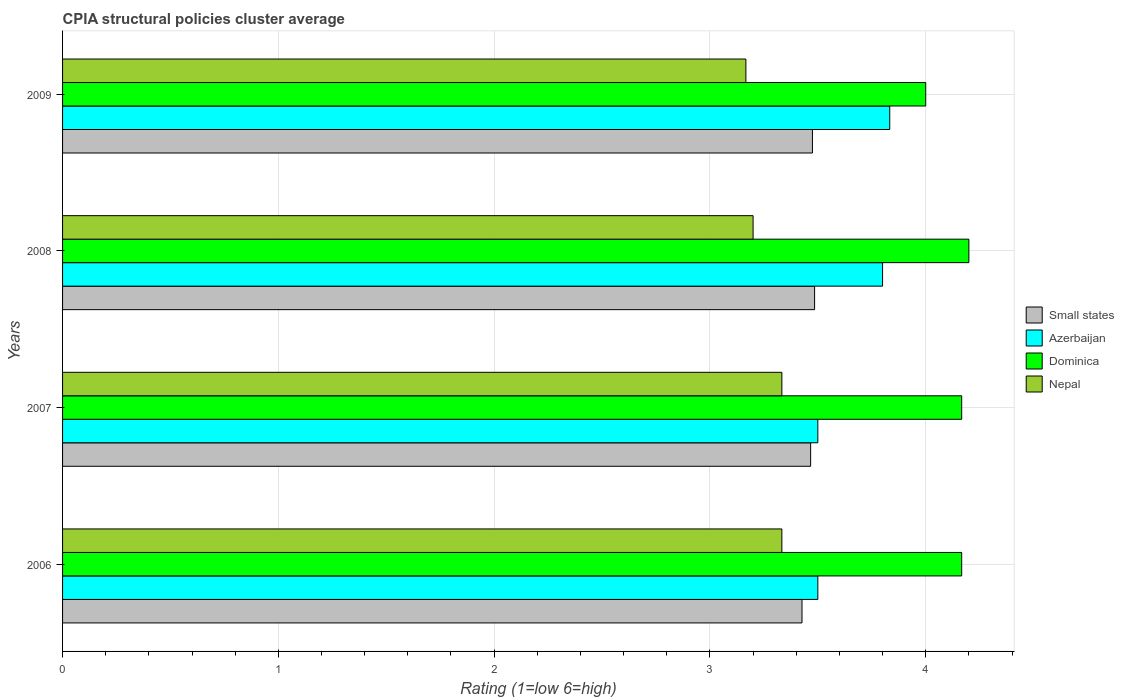Are the number of bars per tick equal to the number of legend labels?
Your response must be concise. Yes. How many bars are there on the 1st tick from the top?
Your answer should be very brief. 4. What is the label of the 2nd group of bars from the top?
Provide a succinct answer. 2008. What is the CPIA rating in Dominica in 2008?
Provide a succinct answer. 4.2. Across all years, what is the maximum CPIA rating in Dominica?
Provide a succinct answer. 4.2. Across all years, what is the minimum CPIA rating in Nepal?
Your answer should be very brief. 3.17. In which year was the CPIA rating in Nepal maximum?
Ensure brevity in your answer.  2006. In which year was the CPIA rating in Small states minimum?
Offer a very short reply. 2006. What is the total CPIA rating in Nepal in the graph?
Make the answer very short. 13.03. What is the difference between the CPIA rating in Nepal in 2006 and that in 2008?
Offer a very short reply. 0.13. What is the difference between the CPIA rating in Small states in 2006 and the CPIA rating in Azerbaijan in 2009?
Ensure brevity in your answer.  -0.41. What is the average CPIA rating in Small states per year?
Give a very brief answer. 3.46. In the year 2006, what is the difference between the CPIA rating in Dominica and CPIA rating in Small states?
Keep it short and to the point. 0.74. What is the ratio of the CPIA rating in Dominica in 2006 to that in 2008?
Offer a very short reply. 0.99. Is the difference between the CPIA rating in Dominica in 2008 and 2009 greater than the difference between the CPIA rating in Small states in 2008 and 2009?
Offer a very short reply. Yes. What is the difference between the highest and the second highest CPIA rating in Dominica?
Your answer should be very brief. 0.03. What is the difference between the highest and the lowest CPIA rating in Nepal?
Ensure brevity in your answer.  0.17. In how many years, is the CPIA rating in Small states greater than the average CPIA rating in Small states taken over all years?
Provide a short and direct response. 3. Is the sum of the CPIA rating in Azerbaijan in 2006 and 2009 greater than the maximum CPIA rating in Nepal across all years?
Ensure brevity in your answer.  Yes. Is it the case that in every year, the sum of the CPIA rating in Dominica and CPIA rating in Small states is greater than the sum of CPIA rating in Azerbaijan and CPIA rating in Nepal?
Make the answer very short. Yes. What does the 2nd bar from the top in 2007 represents?
Keep it short and to the point. Dominica. What does the 2nd bar from the bottom in 2007 represents?
Make the answer very short. Azerbaijan. How many bars are there?
Your response must be concise. 16. How many years are there in the graph?
Offer a very short reply. 4. What is the difference between two consecutive major ticks on the X-axis?
Offer a terse response. 1. Does the graph contain any zero values?
Offer a terse response. No. Does the graph contain grids?
Make the answer very short. Yes. What is the title of the graph?
Your response must be concise. CPIA structural policies cluster average. What is the label or title of the X-axis?
Your answer should be compact. Rating (1=low 6=high). What is the Rating (1=low 6=high) of Small states in 2006?
Offer a terse response. 3.43. What is the Rating (1=low 6=high) of Dominica in 2006?
Give a very brief answer. 4.17. What is the Rating (1=low 6=high) in Nepal in 2006?
Offer a very short reply. 3.33. What is the Rating (1=low 6=high) in Small states in 2007?
Ensure brevity in your answer.  3.47. What is the Rating (1=low 6=high) in Dominica in 2007?
Keep it short and to the point. 4.17. What is the Rating (1=low 6=high) of Nepal in 2007?
Give a very brief answer. 3.33. What is the Rating (1=low 6=high) in Small states in 2008?
Your answer should be compact. 3.48. What is the Rating (1=low 6=high) of Azerbaijan in 2008?
Offer a terse response. 3.8. What is the Rating (1=low 6=high) of Nepal in 2008?
Your answer should be very brief. 3.2. What is the Rating (1=low 6=high) in Small states in 2009?
Offer a very short reply. 3.48. What is the Rating (1=low 6=high) in Azerbaijan in 2009?
Ensure brevity in your answer.  3.83. What is the Rating (1=low 6=high) of Nepal in 2009?
Keep it short and to the point. 3.17. Across all years, what is the maximum Rating (1=low 6=high) of Small states?
Give a very brief answer. 3.48. Across all years, what is the maximum Rating (1=low 6=high) of Azerbaijan?
Provide a short and direct response. 3.83. Across all years, what is the maximum Rating (1=low 6=high) of Dominica?
Give a very brief answer. 4.2. Across all years, what is the maximum Rating (1=low 6=high) of Nepal?
Give a very brief answer. 3.33. Across all years, what is the minimum Rating (1=low 6=high) in Small states?
Provide a short and direct response. 3.43. Across all years, what is the minimum Rating (1=low 6=high) of Azerbaijan?
Your answer should be compact. 3.5. Across all years, what is the minimum Rating (1=low 6=high) in Dominica?
Offer a terse response. 4. Across all years, what is the minimum Rating (1=low 6=high) of Nepal?
Make the answer very short. 3.17. What is the total Rating (1=low 6=high) in Small states in the graph?
Your answer should be very brief. 13.85. What is the total Rating (1=low 6=high) of Azerbaijan in the graph?
Make the answer very short. 14.63. What is the total Rating (1=low 6=high) of Dominica in the graph?
Keep it short and to the point. 16.53. What is the total Rating (1=low 6=high) of Nepal in the graph?
Your response must be concise. 13.03. What is the difference between the Rating (1=low 6=high) in Small states in 2006 and that in 2007?
Your answer should be compact. -0.04. What is the difference between the Rating (1=low 6=high) of Small states in 2006 and that in 2008?
Ensure brevity in your answer.  -0.06. What is the difference between the Rating (1=low 6=high) of Dominica in 2006 and that in 2008?
Keep it short and to the point. -0.03. What is the difference between the Rating (1=low 6=high) in Nepal in 2006 and that in 2008?
Provide a succinct answer. 0.13. What is the difference between the Rating (1=low 6=high) of Small states in 2006 and that in 2009?
Offer a very short reply. -0.05. What is the difference between the Rating (1=low 6=high) in Nepal in 2006 and that in 2009?
Keep it short and to the point. 0.17. What is the difference between the Rating (1=low 6=high) of Small states in 2007 and that in 2008?
Offer a very short reply. -0.02. What is the difference between the Rating (1=low 6=high) in Azerbaijan in 2007 and that in 2008?
Provide a short and direct response. -0.3. What is the difference between the Rating (1=low 6=high) of Dominica in 2007 and that in 2008?
Your response must be concise. -0.03. What is the difference between the Rating (1=low 6=high) of Nepal in 2007 and that in 2008?
Provide a succinct answer. 0.13. What is the difference between the Rating (1=low 6=high) of Small states in 2007 and that in 2009?
Ensure brevity in your answer.  -0.01. What is the difference between the Rating (1=low 6=high) of Small states in 2008 and that in 2009?
Provide a short and direct response. 0.01. What is the difference between the Rating (1=low 6=high) in Azerbaijan in 2008 and that in 2009?
Your answer should be very brief. -0.03. What is the difference between the Rating (1=low 6=high) in Small states in 2006 and the Rating (1=low 6=high) in Azerbaijan in 2007?
Ensure brevity in your answer.  -0.07. What is the difference between the Rating (1=low 6=high) of Small states in 2006 and the Rating (1=low 6=high) of Dominica in 2007?
Offer a very short reply. -0.74. What is the difference between the Rating (1=low 6=high) in Small states in 2006 and the Rating (1=low 6=high) in Nepal in 2007?
Offer a very short reply. 0.09. What is the difference between the Rating (1=low 6=high) in Azerbaijan in 2006 and the Rating (1=low 6=high) in Nepal in 2007?
Your answer should be compact. 0.17. What is the difference between the Rating (1=low 6=high) of Small states in 2006 and the Rating (1=low 6=high) of Azerbaijan in 2008?
Provide a short and direct response. -0.37. What is the difference between the Rating (1=low 6=high) of Small states in 2006 and the Rating (1=low 6=high) of Dominica in 2008?
Ensure brevity in your answer.  -0.77. What is the difference between the Rating (1=low 6=high) in Small states in 2006 and the Rating (1=low 6=high) in Nepal in 2008?
Your answer should be compact. 0.23. What is the difference between the Rating (1=low 6=high) in Dominica in 2006 and the Rating (1=low 6=high) in Nepal in 2008?
Offer a very short reply. 0.97. What is the difference between the Rating (1=low 6=high) in Small states in 2006 and the Rating (1=low 6=high) in Azerbaijan in 2009?
Offer a very short reply. -0.41. What is the difference between the Rating (1=low 6=high) of Small states in 2006 and the Rating (1=low 6=high) of Dominica in 2009?
Provide a succinct answer. -0.57. What is the difference between the Rating (1=low 6=high) in Small states in 2006 and the Rating (1=low 6=high) in Nepal in 2009?
Your answer should be compact. 0.26. What is the difference between the Rating (1=low 6=high) in Small states in 2007 and the Rating (1=low 6=high) in Azerbaijan in 2008?
Your response must be concise. -0.33. What is the difference between the Rating (1=low 6=high) in Small states in 2007 and the Rating (1=low 6=high) in Dominica in 2008?
Provide a short and direct response. -0.73. What is the difference between the Rating (1=low 6=high) of Small states in 2007 and the Rating (1=low 6=high) of Nepal in 2008?
Give a very brief answer. 0.27. What is the difference between the Rating (1=low 6=high) of Dominica in 2007 and the Rating (1=low 6=high) of Nepal in 2008?
Your answer should be compact. 0.97. What is the difference between the Rating (1=low 6=high) in Small states in 2007 and the Rating (1=low 6=high) in Azerbaijan in 2009?
Your response must be concise. -0.37. What is the difference between the Rating (1=low 6=high) of Small states in 2007 and the Rating (1=low 6=high) of Dominica in 2009?
Your answer should be compact. -0.53. What is the difference between the Rating (1=low 6=high) in Small states in 2007 and the Rating (1=low 6=high) in Nepal in 2009?
Your answer should be compact. 0.3. What is the difference between the Rating (1=low 6=high) of Azerbaijan in 2007 and the Rating (1=low 6=high) of Nepal in 2009?
Your response must be concise. 0.33. What is the difference between the Rating (1=low 6=high) of Small states in 2008 and the Rating (1=low 6=high) of Azerbaijan in 2009?
Provide a short and direct response. -0.35. What is the difference between the Rating (1=low 6=high) of Small states in 2008 and the Rating (1=low 6=high) of Dominica in 2009?
Your response must be concise. -0.52. What is the difference between the Rating (1=low 6=high) of Small states in 2008 and the Rating (1=low 6=high) of Nepal in 2009?
Offer a very short reply. 0.32. What is the difference between the Rating (1=low 6=high) in Azerbaijan in 2008 and the Rating (1=low 6=high) in Dominica in 2009?
Ensure brevity in your answer.  -0.2. What is the difference between the Rating (1=low 6=high) of Azerbaijan in 2008 and the Rating (1=low 6=high) of Nepal in 2009?
Make the answer very short. 0.63. What is the difference between the Rating (1=low 6=high) in Dominica in 2008 and the Rating (1=low 6=high) in Nepal in 2009?
Provide a short and direct response. 1.03. What is the average Rating (1=low 6=high) in Small states per year?
Offer a terse response. 3.46. What is the average Rating (1=low 6=high) of Azerbaijan per year?
Give a very brief answer. 3.66. What is the average Rating (1=low 6=high) in Dominica per year?
Provide a short and direct response. 4.13. What is the average Rating (1=low 6=high) of Nepal per year?
Your answer should be compact. 3.26. In the year 2006, what is the difference between the Rating (1=low 6=high) in Small states and Rating (1=low 6=high) in Azerbaijan?
Ensure brevity in your answer.  -0.07. In the year 2006, what is the difference between the Rating (1=low 6=high) in Small states and Rating (1=low 6=high) in Dominica?
Ensure brevity in your answer.  -0.74. In the year 2006, what is the difference between the Rating (1=low 6=high) in Small states and Rating (1=low 6=high) in Nepal?
Provide a succinct answer. 0.09. In the year 2006, what is the difference between the Rating (1=low 6=high) of Azerbaijan and Rating (1=low 6=high) of Dominica?
Offer a terse response. -0.67. In the year 2006, what is the difference between the Rating (1=low 6=high) in Azerbaijan and Rating (1=low 6=high) in Nepal?
Offer a very short reply. 0.17. In the year 2006, what is the difference between the Rating (1=low 6=high) of Dominica and Rating (1=low 6=high) of Nepal?
Provide a succinct answer. 0.83. In the year 2007, what is the difference between the Rating (1=low 6=high) of Small states and Rating (1=low 6=high) of Azerbaijan?
Provide a short and direct response. -0.03. In the year 2007, what is the difference between the Rating (1=low 6=high) of Small states and Rating (1=low 6=high) of Nepal?
Ensure brevity in your answer.  0.13. In the year 2007, what is the difference between the Rating (1=low 6=high) in Azerbaijan and Rating (1=low 6=high) in Nepal?
Your answer should be very brief. 0.17. In the year 2008, what is the difference between the Rating (1=low 6=high) in Small states and Rating (1=low 6=high) in Azerbaijan?
Make the answer very short. -0.32. In the year 2008, what is the difference between the Rating (1=low 6=high) of Small states and Rating (1=low 6=high) of Dominica?
Your response must be concise. -0.71. In the year 2008, what is the difference between the Rating (1=low 6=high) of Small states and Rating (1=low 6=high) of Nepal?
Your answer should be very brief. 0.28. In the year 2008, what is the difference between the Rating (1=low 6=high) in Azerbaijan and Rating (1=low 6=high) in Dominica?
Your response must be concise. -0.4. In the year 2008, what is the difference between the Rating (1=low 6=high) of Azerbaijan and Rating (1=low 6=high) of Nepal?
Provide a succinct answer. 0.6. In the year 2009, what is the difference between the Rating (1=low 6=high) of Small states and Rating (1=low 6=high) of Azerbaijan?
Offer a terse response. -0.36. In the year 2009, what is the difference between the Rating (1=low 6=high) of Small states and Rating (1=low 6=high) of Dominica?
Your answer should be very brief. -0.53. In the year 2009, what is the difference between the Rating (1=low 6=high) in Small states and Rating (1=low 6=high) in Nepal?
Provide a succinct answer. 0.31. In the year 2009, what is the difference between the Rating (1=low 6=high) of Azerbaijan and Rating (1=low 6=high) of Dominica?
Your response must be concise. -0.17. In the year 2009, what is the difference between the Rating (1=low 6=high) of Azerbaijan and Rating (1=low 6=high) of Nepal?
Provide a succinct answer. 0.67. What is the ratio of the Rating (1=low 6=high) of Small states in 2006 to that in 2007?
Provide a short and direct response. 0.99. What is the ratio of the Rating (1=low 6=high) of Azerbaijan in 2006 to that in 2007?
Make the answer very short. 1. What is the ratio of the Rating (1=low 6=high) in Dominica in 2006 to that in 2007?
Make the answer very short. 1. What is the ratio of the Rating (1=low 6=high) in Small states in 2006 to that in 2008?
Provide a succinct answer. 0.98. What is the ratio of the Rating (1=low 6=high) in Azerbaijan in 2006 to that in 2008?
Offer a very short reply. 0.92. What is the ratio of the Rating (1=low 6=high) of Dominica in 2006 to that in 2008?
Keep it short and to the point. 0.99. What is the ratio of the Rating (1=low 6=high) of Nepal in 2006 to that in 2008?
Ensure brevity in your answer.  1.04. What is the ratio of the Rating (1=low 6=high) of Small states in 2006 to that in 2009?
Make the answer very short. 0.99. What is the ratio of the Rating (1=low 6=high) of Dominica in 2006 to that in 2009?
Provide a short and direct response. 1.04. What is the ratio of the Rating (1=low 6=high) of Nepal in 2006 to that in 2009?
Your answer should be very brief. 1.05. What is the ratio of the Rating (1=low 6=high) in Azerbaijan in 2007 to that in 2008?
Provide a succinct answer. 0.92. What is the ratio of the Rating (1=low 6=high) in Dominica in 2007 to that in 2008?
Ensure brevity in your answer.  0.99. What is the ratio of the Rating (1=low 6=high) in Nepal in 2007 to that in 2008?
Give a very brief answer. 1.04. What is the ratio of the Rating (1=low 6=high) in Small states in 2007 to that in 2009?
Offer a very short reply. 1. What is the ratio of the Rating (1=low 6=high) of Dominica in 2007 to that in 2009?
Provide a short and direct response. 1.04. What is the ratio of the Rating (1=low 6=high) in Nepal in 2007 to that in 2009?
Offer a terse response. 1.05. What is the ratio of the Rating (1=low 6=high) in Small states in 2008 to that in 2009?
Your response must be concise. 1. What is the ratio of the Rating (1=low 6=high) of Azerbaijan in 2008 to that in 2009?
Provide a succinct answer. 0.99. What is the ratio of the Rating (1=low 6=high) of Dominica in 2008 to that in 2009?
Ensure brevity in your answer.  1.05. What is the ratio of the Rating (1=low 6=high) of Nepal in 2008 to that in 2009?
Your response must be concise. 1.01. What is the difference between the highest and the second highest Rating (1=low 6=high) in Dominica?
Provide a succinct answer. 0.03. What is the difference between the highest and the lowest Rating (1=low 6=high) in Small states?
Keep it short and to the point. 0.06. 